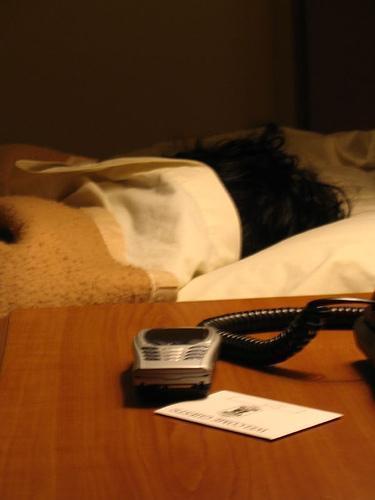How many beds are there?
Give a very brief answer. 1. 